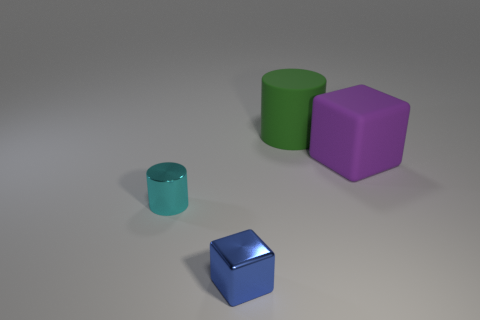Add 3 tiny brown shiny blocks. How many objects exist? 7 Subtract all brown cubes. Subtract all large green matte things. How many objects are left? 3 Add 3 rubber cylinders. How many rubber cylinders are left? 4 Add 2 large green metal cylinders. How many large green metal cylinders exist? 2 Subtract 0 green cubes. How many objects are left? 4 